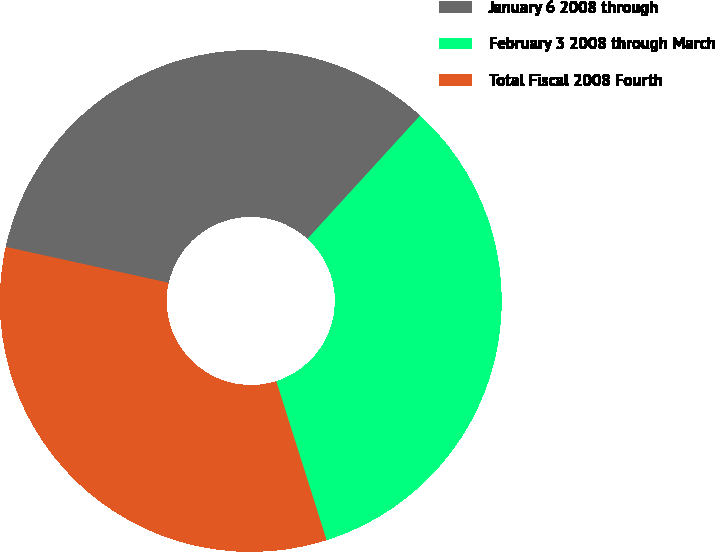<chart> <loc_0><loc_0><loc_500><loc_500><pie_chart><fcel>January 6 2008 through<fcel>February 3 2008 through March<fcel>Total Fiscal 2008 Fourth<nl><fcel>33.33%<fcel>33.33%<fcel>33.33%<nl></chart> 